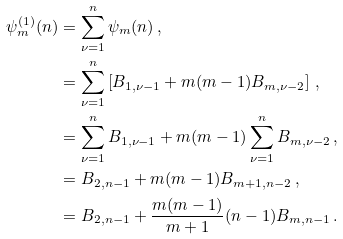<formula> <loc_0><loc_0><loc_500><loc_500>\psi _ { m } ^ { ( 1 ) } ( n ) & = \sum _ { \nu = 1 } ^ { n } \psi _ { m } ( n ) \, , \\ & = \sum _ { \nu = 1 } ^ { n } \left [ B _ { 1 , \nu - 1 } + m ( m - 1 ) B _ { m , \nu - 2 } \right ] \, , \\ & = \sum _ { \nu = 1 } ^ { n } B _ { 1 , \nu - 1 } + m ( m - 1 ) \sum _ { \nu = 1 } ^ { n } B _ { m , \nu - 2 } \, , \\ & = B _ { 2 , n - 1 } + m ( m - 1 ) B _ { m + 1 , n - 2 } \, , \\ & = B _ { 2 , n - 1 } + \frac { m ( m - 1 ) } { m + 1 } ( n - 1 ) B _ { m , n - 1 } \, .</formula> 